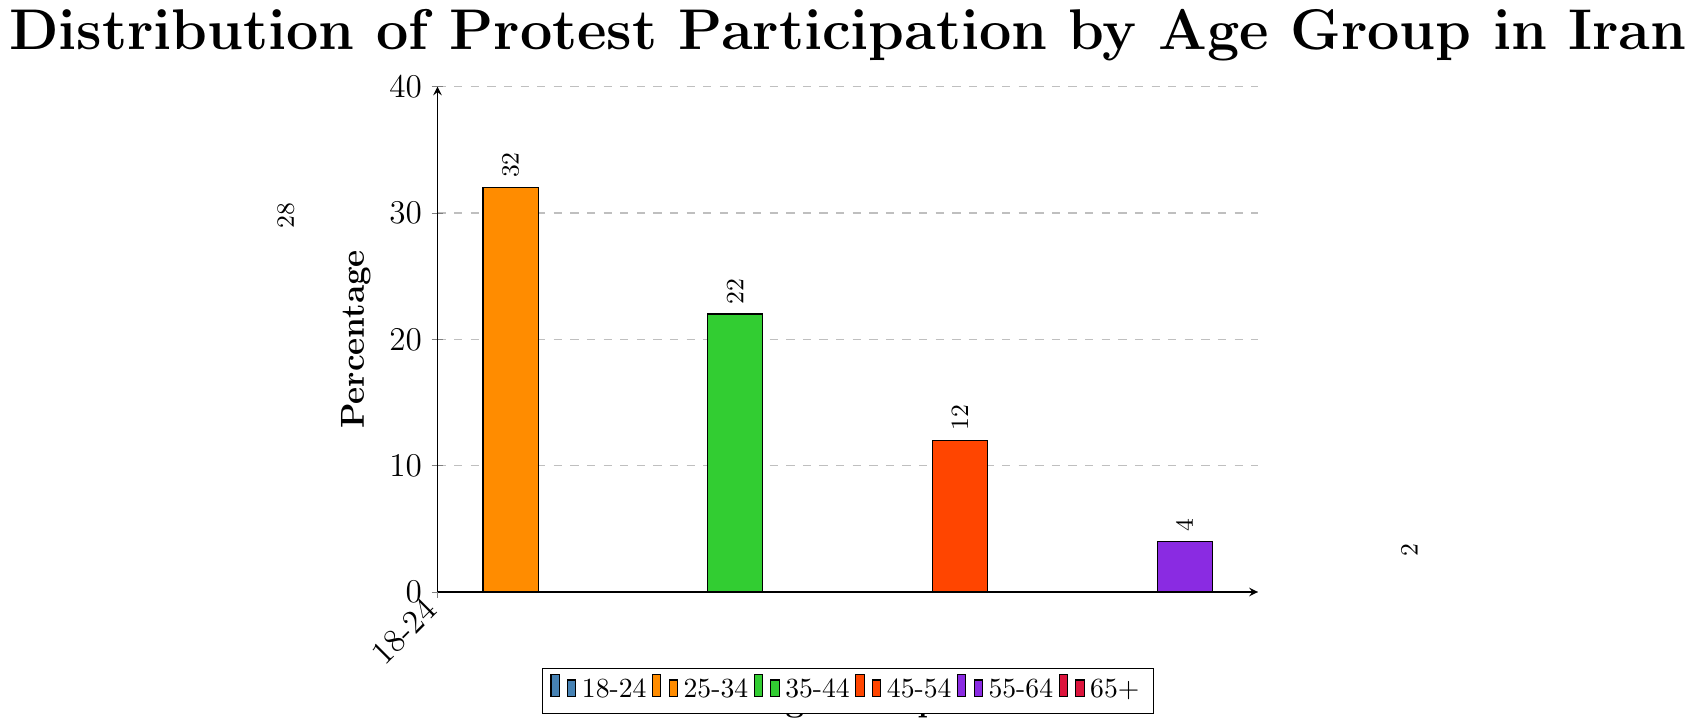Which age group has the highest percentage of protest participation? By examining the height of the bars, the 25-34 age group has the tallest bar, indicating the highest percentage of protest participation.
Answer: 25-34 Which age group has the lowest percentage of protest participation? By looking at the height of the bars, the 65+ age group has the shortest bar, indicating the lowest percentage of protest participation.
Answer: 65+ What is the total percentage of protest participation for the age groups 35-44 and 45-54? Adding the percentages of the 35-44 age group (22%) with the 45-54 age group (12%) gives 34%.
Answer: 34% What is the difference in protest participation percentage between the 18-24 and 55-64 age groups? Subtracting the percentage of the 55-64 age group (4%) from the 18-24 age group (28%) gives 24%.
Answer: 24% Which color represents the age group with the third highest protest participation percentage? Identifying the age group with the third highest percentage, we see that 35-44 is represented by the green bar.
Answer: green How much greater is the protest participation percentage of the 25-34 age group compared to the 55-64 age group? Subtracting the percentage of the 55-64 age group (4%) from the 25-34 age group (32%) gives 28%.
Answer: 28% What is the combined percentage of protest participants for age groups under 35? Adding the percentages of the 18-24 age group (28%) and the 25-34 age group (32%) gives a total of 60%.
Answer: 60% Is the protest participation percentage of the 45-54 age group greater than that of the 55-64 age group? Comparing the two percentages, 12% (45-54) is greater than 4% (55-64).
Answer: yes By how many percentage points does the 25-34 age group exceed the 35-44 age group in protest participation? Subtracting the percentage of the 35-44 age group (22%) from the 25-34 age group (32%) gives 10%.
Answer: 10% What is the average percentage of protest participation across all age groups? Adding the percentages (28, 32, 22, 12, 4, 2) gives a total of 100. Dividing by the number of age groups (6) gives the average, 100/6, which is approximately 16.67%.
Answer: 16.67% 